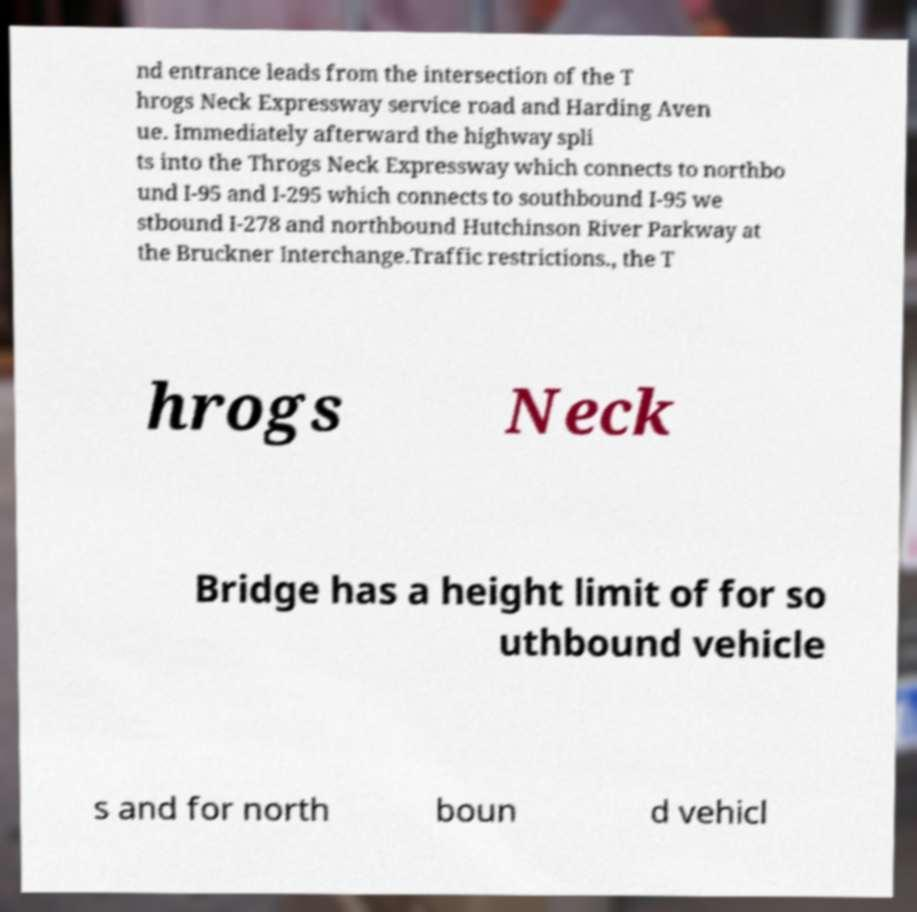Please read and relay the text visible in this image. What does it say? nd entrance leads from the intersection of the T hrogs Neck Expressway service road and Harding Aven ue. Immediately afterward the highway spli ts into the Throgs Neck Expressway which connects to northbo und I-95 and I-295 which connects to southbound I-95 we stbound I-278 and northbound Hutchinson River Parkway at the Bruckner Interchange.Traffic restrictions., the T hrogs Neck Bridge has a height limit of for so uthbound vehicle s and for north boun d vehicl 